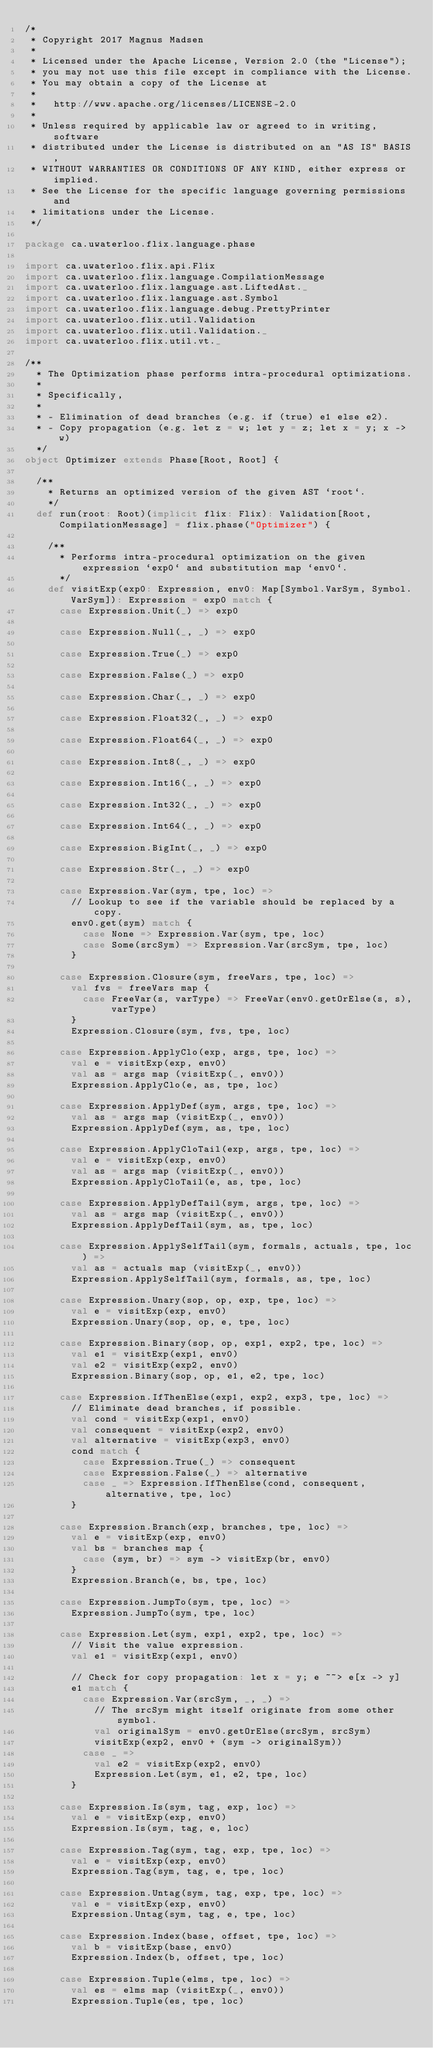Convert code to text. <code><loc_0><loc_0><loc_500><loc_500><_Scala_>/*
 * Copyright 2017 Magnus Madsen
 *
 * Licensed under the Apache License, Version 2.0 (the "License");
 * you may not use this file except in compliance with the License.
 * You may obtain a copy of the License at
 *
 *   http://www.apache.org/licenses/LICENSE-2.0
 *
 * Unless required by applicable law or agreed to in writing, software
 * distributed under the License is distributed on an "AS IS" BASIS,
 * WITHOUT WARRANTIES OR CONDITIONS OF ANY KIND, either express or implied.
 * See the License for the specific language governing permissions and
 * limitations under the License.
 */

package ca.uwaterloo.flix.language.phase

import ca.uwaterloo.flix.api.Flix
import ca.uwaterloo.flix.language.CompilationMessage
import ca.uwaterloo.flix.language.ast.LiftedAst._
import ca.uwaterloo.flix.language.ast.Symbol
import ca.uwaterloo.flix.language.debug.PrettyPrinter
import ca.uwaterloo.flix.util.Validation
import ca.uwaterloo.flix.util.Validation._
import ca.uwaterloo.flix.util.vt._

/**
  * The Optimization phase performs intra-procedural optimizations.
  *
  * Specifically,
  *
  * - Elimination of dead branches (e.g. if (true) e1 else e2).
  * - Copy propagation (e.g. let z = w; let y = z; let x = y; x -> w)
  */
object Optimizer extends Phase[Root, Root] {

  /**
    * Returns an optimized version of the given AST `root`.
    */
  def run(root: Root)(implicit flix: Flix): Validation[Root, CompilationMessage] = flix.phase("Optimizer") {

    /**
      * Performs intra-procedural optimization on the given expression `exp0` and substitution map `env0`.
      */
    def visitExp(exp0: Expression, env0: Map[Symbol.VarSym, Symbol.VarSym]): Expression = exp0 match {
      case Expression.Unit(_) => exp0

      case Expression.Null(_, _) => exp0

      case Expression.True(_) => exp0

      case Expression.False(_) => exp0

      case Expression.Char(_, _) => exp0

      case Expression.Float32(_, _) => exp0

      case Expression.Float64(_, _) => exp0

      case Expression.Int8(_, _) => exp0

      case Expression.Int16(_, _) => exp0

      case Expression.Int32(_, _) => exp0

      case Expression.Int64(_, _) => exp0

      case Expression.BigInt(_, _) => exp0

      case Expression.Str(_, _) => exp0

      case Expression.Var(sym, tpe, loc) =>
        // Lookup to see if the variable should be replaced by a copy.
        env0.get(sym) match {
          case None => Expression.Var(sym, tpe, loc)
          case Some(srcSym) => Expression.Var(srcSym, tpe, loc)
        }

      case Expression.Closure(sym, freeVars, tpe, loc) =>
        val fvs = freeVars map {
          case FreeVar(s, varType) => FreeVar(env0.getOrElse(s, s), varType)
        }
        Expression.Closure(sym, fvs, tpe, loc)

      case Expression.ApplyClo(exp, args, tpe, loc) =>
        val e = visitExp(exp, env0)
        val as = args map (visitExp(_, env0))
        Expression.ApplyClo(e, as, tpe, loc)

      case Expression.ApplyDef(sym, args, tpe, loc) =>
        val as = args map (visitExp(_, env0))
        Expression.ApplyDef(sym, as, tpe, loc)

      case Expression.ApplyCloTail(exp, args, tpe, loc) =>
        val e = visitExp(exp, env0)
        val as = args map (visitExp(_, env0))
        Expression.ApplyCloTail(e, as, tpe, loc)

      case Expression.ApplyDefTail(sym, args, tpe, loc) =>
        val as = args map (visitExp(_, env0))
        Expression.ApplyDefTail(sym, as, tpe, loc)

      case Expression.ApplySelfTail(sym, formals, actuals, tpe, loc) =>
        val as = actuals map (visitExp(_, env0))
        Expression.ApplySelfTail(sym, formals, as, tpe, loc)

      case Expression.Unary(sop, op, exp, tpe, loc) =>
        val e = visitExp(exp, env0)
        Expression.Unary(sop, op, e, tpe, loc)

      case Expression.Binary(sop, op, exp1, exp2, tpe, loc) =>
        val e1 = visitExp(exp1, env0)
        val e2 = visitExp(exp2, env0)
        Expression.Binary(sop, op, e1, e2, tpe, loc)

      case Expression.IfThenElse(exp1, exp2, exp3, tpe, loc) =>
        // Eliminate dead branches, if possible.
        val cond = visitExp(exp1, env0)
        val consequent = visitExp(exp2, env0)
        val alternative = visitExp(exp3, env0)
        cond match {
          case Expression.True(_) => consequent
          case Expression.False(_) => alternative
          case _ => Expression.IfThenElse(cond, consequent, alternative, tpe, loc)
        }

      case Expression.Branch(exp, branches, tpe, loc) =>
        val e = visitExp(exp, env0)
        val bs = branches map {
          case (sym, br) => sym -> visitExp(br, env0)
        }
        Expression.Branch(e, bs, tpe, loc)

      case Expression.JumpTo(sym, tpe, loc) =>
        Expression.JumpTo(sym, tpe, loc)

      case Expression.Let(sym, exp1, exp2, tpe, loc) =>
        // Visit the value expression.
        val e1 = visitExp(exp1, env0)

        // Check for copy propagation: let x = y; e ~~> e[x -> y]
        e1 match {
          case Expression.Var(srcSym, _, _) =>
            // The srcSym might itself originate from some other symbol.
            val originalSym = env0.getOrElse(srcSym, srcSym)
            visitExp(exp2, env0 + (sym -> originalSym))
          case _ =>
            val e2 = visitExp(exp2, env0)
            Expression.Let(sym, e1, e2, tpe, loc)
        }

      case Expression.Is(sym, tag, exp, loc) =>
        val e = visitExp(exp, env0)
        Expression.Is(sym, tag, e, loc)

      case Expression.Tag(sym, tag, exp, tpe, loc) =>
        val e = visitExp(exp, env0)
        Expression.Tag(sym, tag, e, tpe, loc)

      case Expression.Untag(sym, tag, exp, tpe, loc) =>
        val e = visitExp(exp, env0)
        Expression.Untag(sym, tag, e, tpe, loc)

      case Expression.Index(base, offset, tpe, loc) =>
        val b = visitExp(base, env0)
        Expression.Index(b, offset, tpe, loc)

      case Expression.Tuple(elms, tpe, loc) =>
        val es = elms map (visitExp(_, env0))
        Expression.Tuple(es, tpe, loc)
</code> 